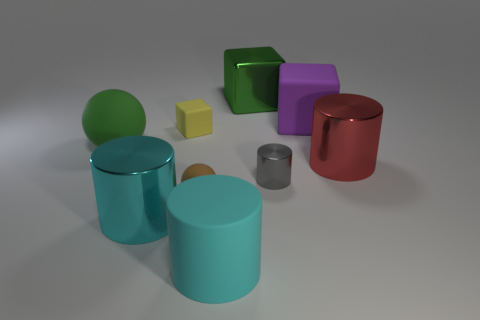What objects are closer to us, and which objects are farther away? The objects closer to us in the image are the two cylinders in front – the larger cyan one and the smaller gray one. Farther away are the yellow cube, the purple cube, and the large red cylinder. The largest cyan cylinder and the green sphere are situated approximately at mid-distance. 